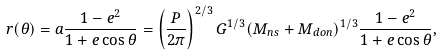Convert formula to latex. <formula><loc_0><loc_0><loc_500><loc_500>r ( \theta ) = a \frac { 1 - e ^ { 2 } } { 1 + e \cos \theta } = \left ( \frac { P } { 2 \pi } \right ) ^ { 2 / 3 } G ^ { 1 / 3 } ( M _ { n s } + M _ { d o n } ) ^ { 1 / 3 } \frac { 1 - e ^ { 2 } } { 1 + e \cos \theta } ,</formula> 